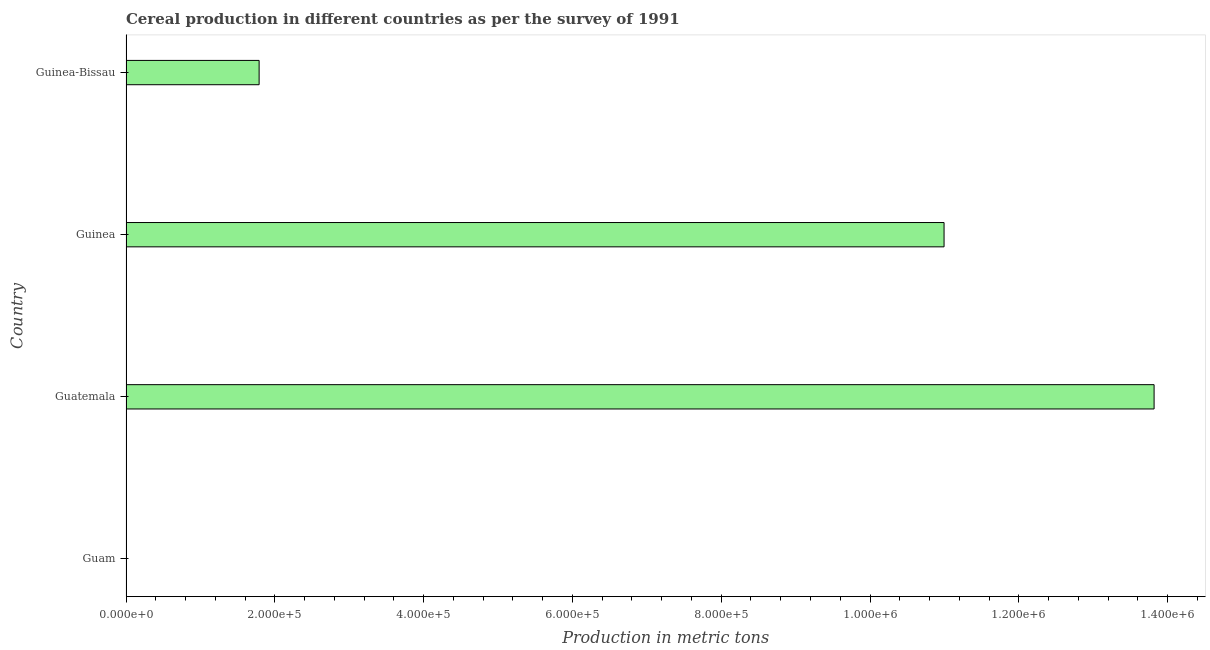Does the graph contain grids?
Your answer should be very brief. No. What is the title of the graph?
Provide a short and direct response. Cereal production in different countries as per the survey of 1991. What is the label or title of the X-axis?
Keep it short and to the point. Production in metric tons. What is the cereal production in Guinea?
Your answer should be compact. 1.10e+06. Across all countries, what is the maximum cereal production?
Your answer should be compact. 1.38e+06. In which country was the cereal production maximum?
Your answer should be very brief. Guatemala. In which country was the cereal production minimum?
Ensure brevity in your answer.  Guam. What is the sum of the cereal production?
Provide a succinct answer. 2.66e+06. What is the difference between the cereal production in Guam and Guatemala?
Give a very brief answer. -1.38e+06. What is the average cereal production per country?
Provide a short and direct response. 6.65e+05. What is the median cereal production?
Your response must be concise. 6.39e+05. What is the ratio of the cereal production in Guatemala to that in Guinea?
Provide a short and direct response. 1.26. Is the cereal production in Guam less than that in Guatemala?
Your answer should be compact. Yes. What is the difference between the highest and the second highest cereal production?
Keep it short and to the point. 2.82e+05. Is the sum of the cereal production in Guatemala and Guinea-Bissau greater than the maximum cereal production across all countries?
Offer a very short reply. Yes. What is the difference between the highest and the lowest cereal production?
Provide a short and direct response. 1.38e+06. In how many countries, is the cereal production greater than the average cereal production taken over all countries?
Your answer should be compact. 2. How many bars are there?
Offer a very short reply. 4. What is the difference between two consecutive major ticks on the X-axis?
Provide a succinct answer. 2.00e+05. What is the Production in metric tons of Guatemala?
Give a very brief answer. 1.38e+06. What is the Production in metric tons of Guinea?
Your answer should be very brief. 1.10e+06. What is the Production in metric tons of Guinea-Bissau?
Make the answer very short. 1.79e+05. What is the difference between the Production in metric tons in Guam and Guatemala?
Provide a succinct answer. -1.38e+06. What is the difference between the Production in metric tons in Guam and Guinea?
Offer a very short reply. -1.10e+06. What is the difference between the Production in metric tons in Guam and Guinea-Bissau?
Your response must be concise. -1.79e+05. What is the difference between the Production in metric tons in Guatemala and Guinea?
Make the answer very short. 2.82e+05. What is the difference between the Production in metric tons in Guatemala and Guinea-Bissau?
Give a very brief answer. 1.20e+06. What is the difference between the Production in metric tons in Guinea and Guinea-Bissau?
Keep it short and to the point. 9.21e+05. What is the ratio of the Production in metric tons in Guam to that in Guatemala?
Keep it short and to the point. 0. What is the ratio of the Production in metric tons in Guam to that in Guinea?
Give a very brief answer. 0. What is the ratio of the Production in metric tons in Guatemala to that in Guinea?
Give a very brief answer. 1.26. What is the ratio of the Production in metric tons in Guatemala to that in Guinea-Bissau?
Give a very brief answer. 7.72. What is the ratio of the Production in metric tons in Guinea to that in Guinea-Bissau?
Offer a very short reply. 6.14. 